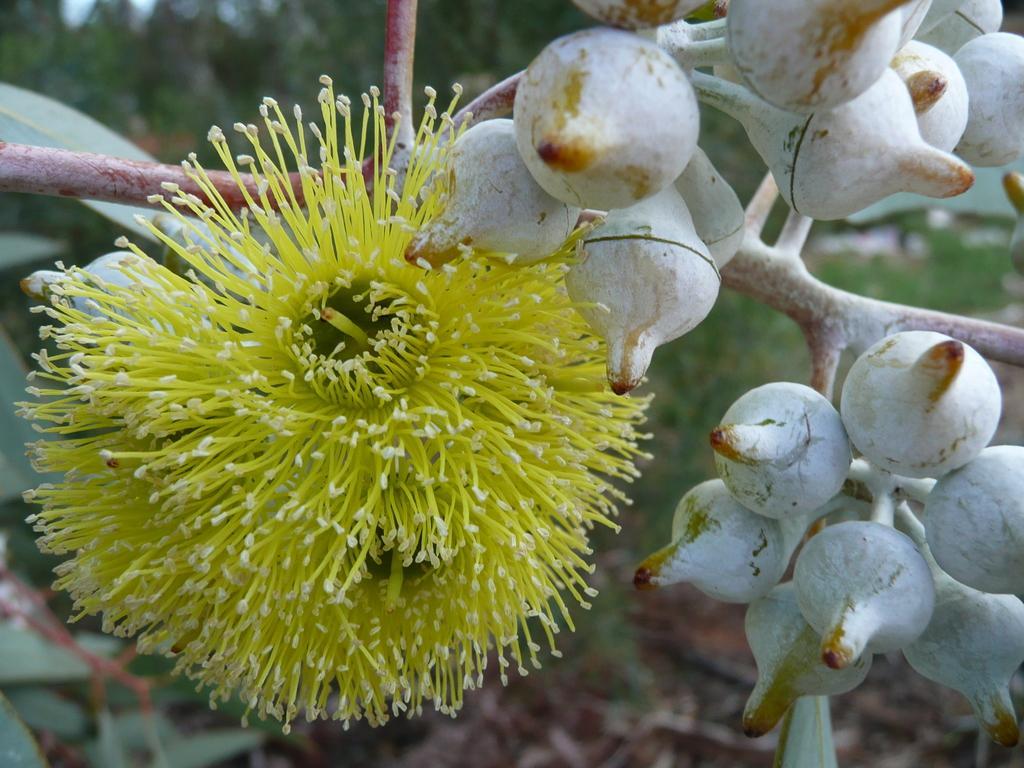Please provide a concise description of this image. In this image there are flowers and buds on the stem. In the background of the image there are trees. 